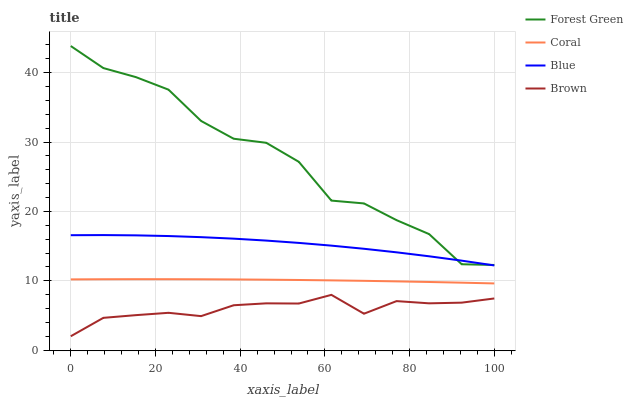Does Brown have the minimum area under the curve?
Answer yes or no. Yes. Does Forest Green have the maximum area under the curve?
Answer yes or no. Yes. Does Forest Green have the minimum area under the curve?
Answer yes or no. No. Does Brown have the maximum area under the curve?
Answer yes or no. No. Is Coral the smoothest?
Answer yes or no. Yes. Is Forest Green the roughest?
Answer yes or no. Yes. Is Brown the smoothest?
Answer yes or no. No. Is Brown the roughest?
Answer yes or no. No. Does Brown have the lowest value?
Answer yes or no. Yes. Does Forest Green have the lowest value?
Answer yes or no. No. Does Forest Green have the highest value?
Answer yes or no. Yes. Does Brown have the highest value?
Answer yes or no. No. Is Brown less than Coral?
Answer yes or no. Yes. Is Blue greater than Brown?
Answer yes or no. Yes. Does Forest Green intersect Blue?
Answer yes or no. Yes. Is Forest Green less than Blue?
Answer yes or no. No. Is Forest Green greater than Blue?
Answer yes or no. No. Does Brown intersect Coral?
Answer yes or no. No. 